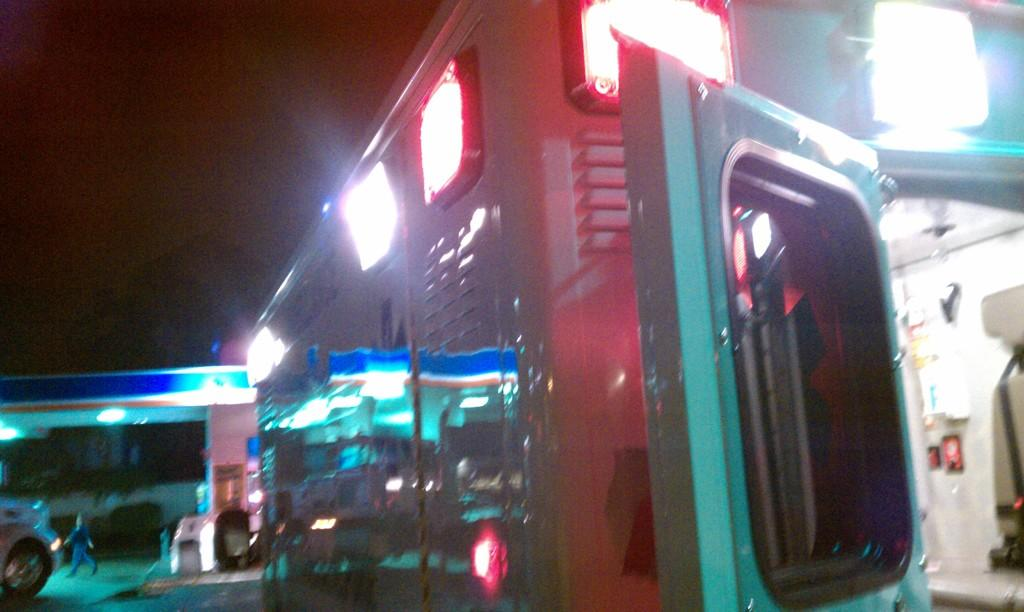What is located on the right side of the image? There is a machine with lights on the right side of the image. What is happening on the left side of the image? A person is walking on the left side of the image. What type of wire is being used to support the person's belief in the image? There is no wire or belief mentioned in the image; it only shows a machine with lights and a person walking. 